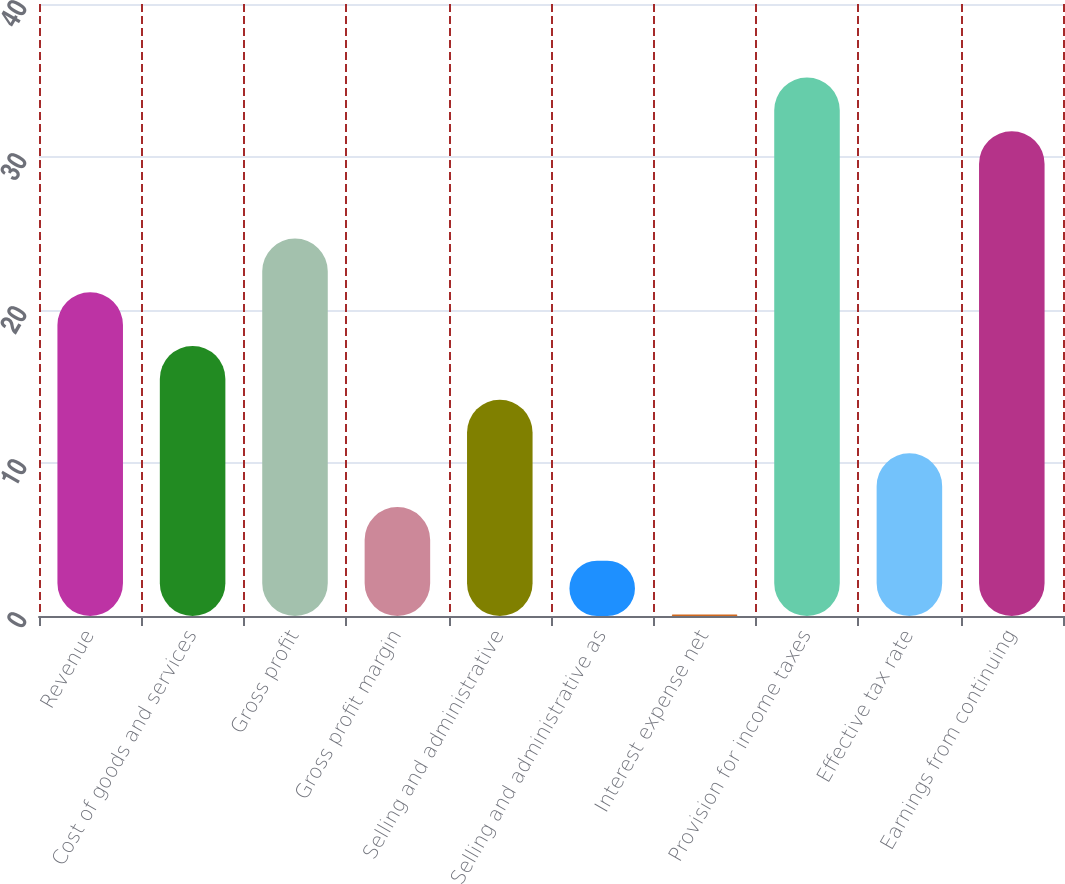<chart> <loc_0><loc_0><loc_500><loc_500><bar_chart><fcel>Revenue<fcel>Cost of goods and services<fcel>Gross profit<fcel>Gross profit margin<fcel>Selling and administrative<fcel>Selling and administrative as<fcel>Interest expense net<fcel>Provision for income taxes<fcel>Effective tax rate<fcel>Earnings from continuing<nl><fcel>21.16<fcel>17.65<fcel>24.67<fcel>7.12<fcel>14.14<fcel>3.61<fcel>0.1<fcel>35.2<fcel>10.63<fcel>31.69<nl></chart> 